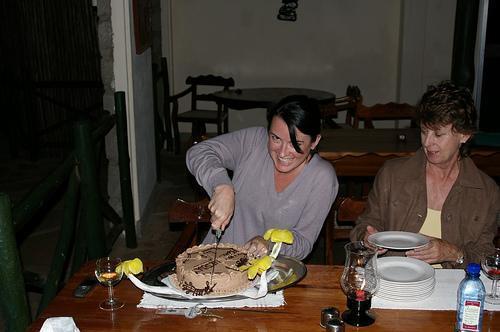How many women are at the table?
Give a very brief answer. 2. How many women are in the picture?
Give a very brief answer. 2. How many people are in the photo?
Give a very brief answer. 2. How many dining tables are visible?
Give a very brief answer. 3. How many chairs are in the picture?
Give a very brief answer. 2. 